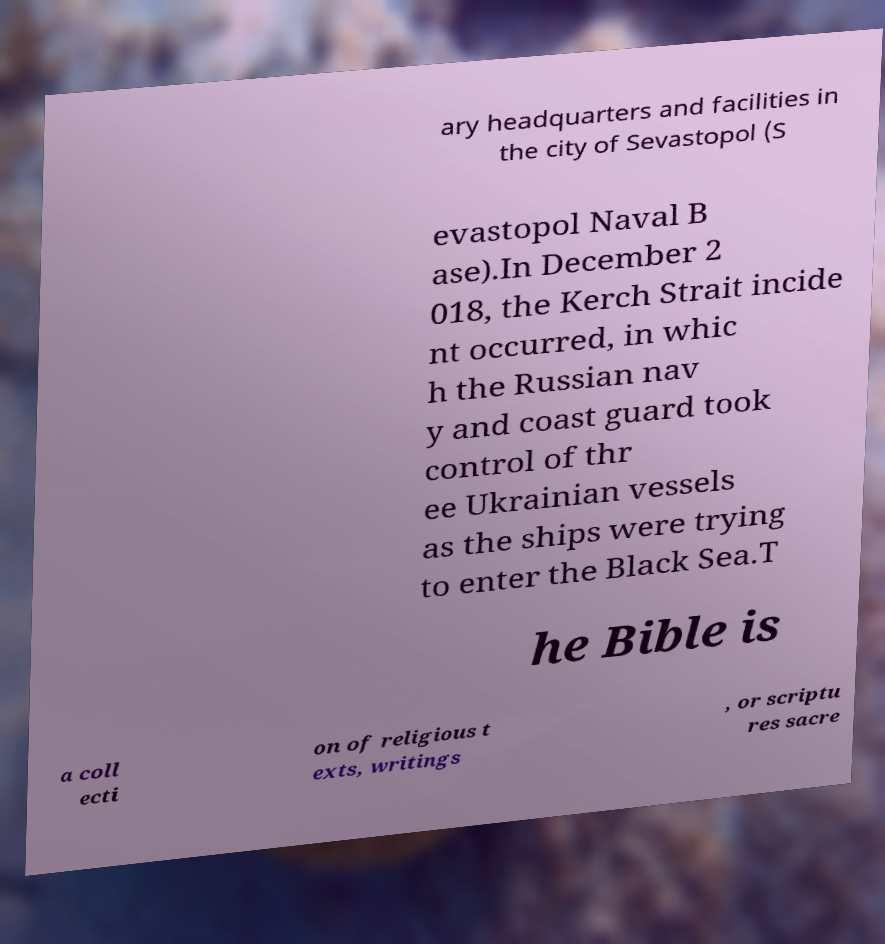There's text embedded in this image that I need extracted. Can you transcribe it verbatim? ary headquarters and facilities in the city of Sevastopol (S evastopol Naval B ase).In December 2 018, the Kerch Strait incide nt occurred, in whic h the Russian nav y and coast guard took control of thr ee Ukrainian vessels as the ships were trying to enter the Black Sea.T he Bible is a coll ecti on of religious t exts, writings , or scriptu res sacre 